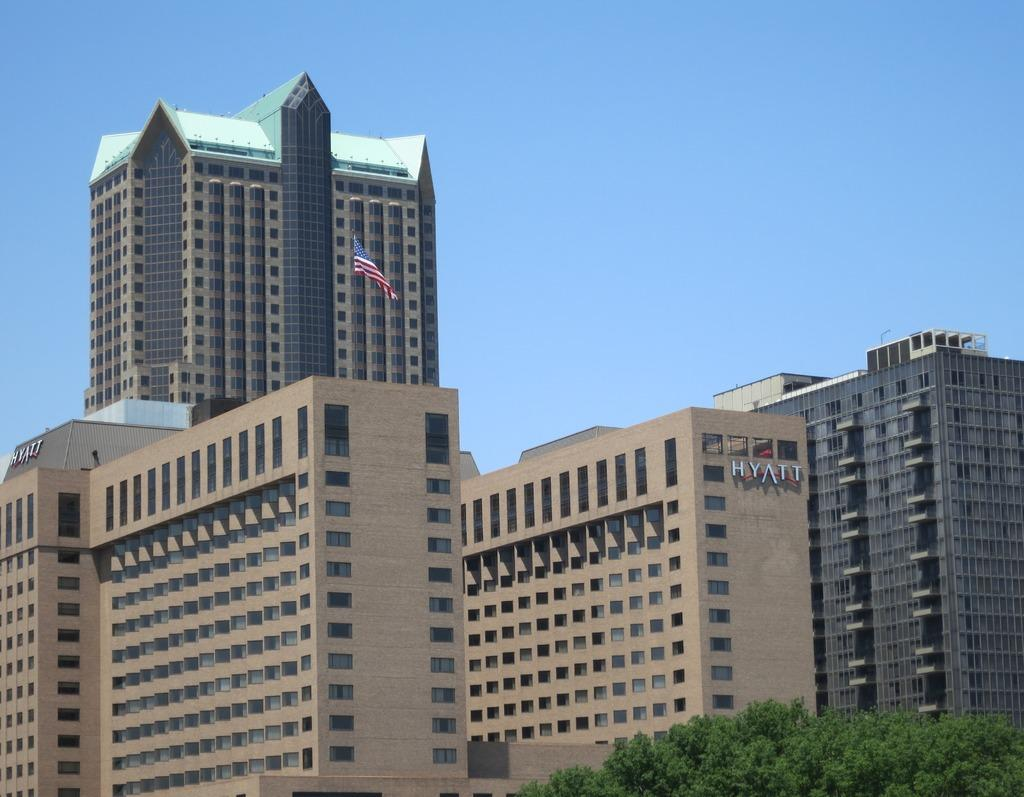What type of structures are present in the image? There are buildings in the image. What is located in the middle of the image? There is a flag in the middle of the image. What type of vegetation can be seen at the right bottom of the image? There are trees at the right bottom of the image. What is visible at the top of the image? The sky is visible at the top of the image. Can you tell me how many plants are crying in the image? There are no plants or crying depicted in the image. Where is the toothbrush located in the image? There is no toothbrush present in the image. 